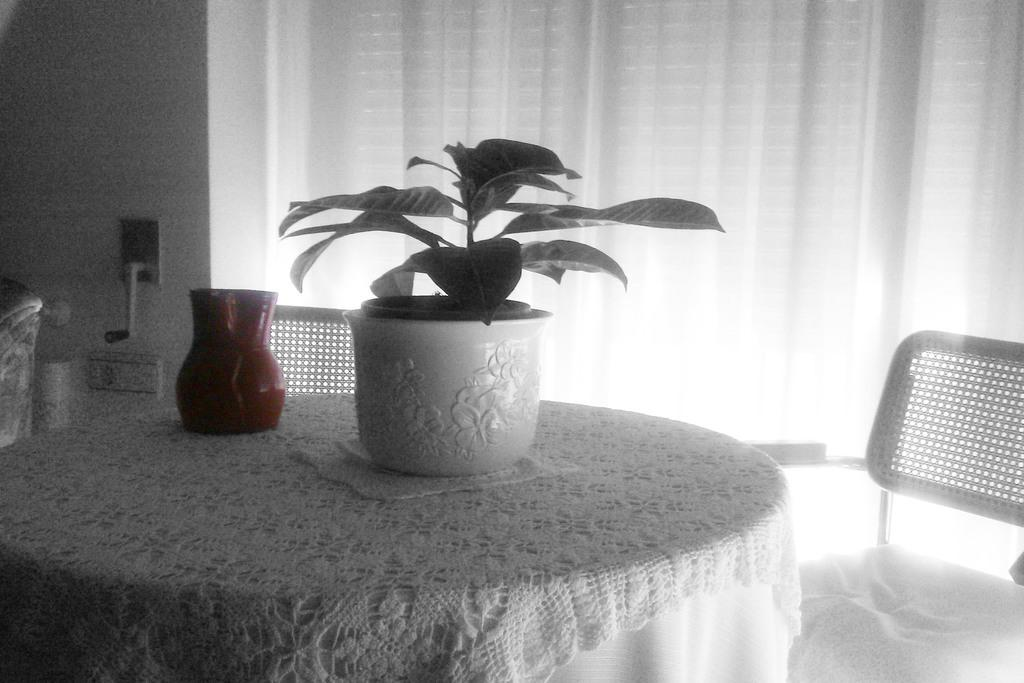What type of furniture is present in the image? There is a table and two chairs in the image. What is placed on the table? There is a plant with a pot on the table. What type of window treatment is visible in the image? There is a curtain visible in the image. What type of earth can be seen in the image? There is no earth visible in the image; it features a table, chairs, a plant with a pot, and a curtain. What book is the person reading in the image? There is no person reading a book in the image. 